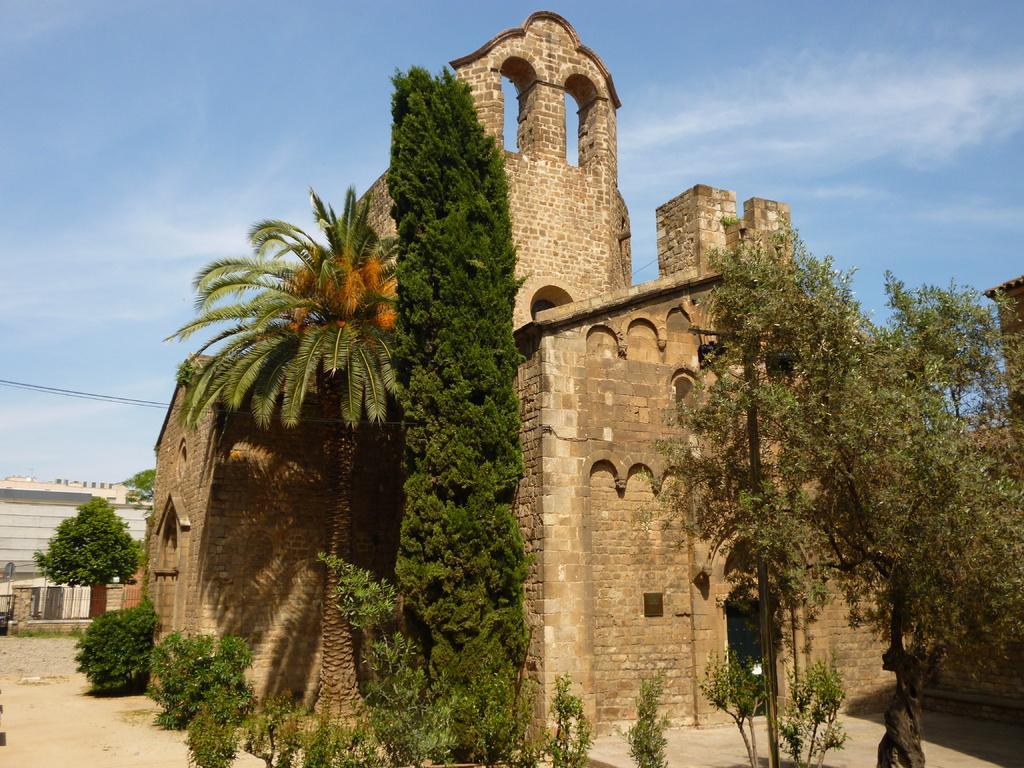Can you describe this image briefly? We can see for,trees and plants. In the background we can see wall,trees,wires and sky. 